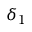Convert formula to latex. <formula><loc_0><loc_0><loc_500><loc_500>\delta _ { 1 }</formula> 